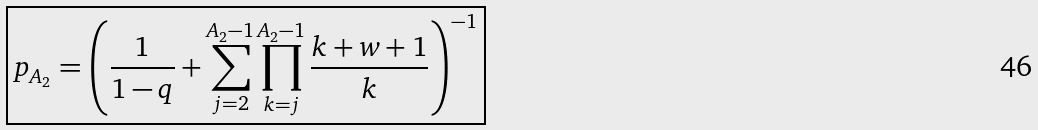<formula> <loc_0><loc_0><loc_500><loc_500>\boxed { p _ { A _ { 2 } } = \left ( \frac { 1 } { 1 - q } + \sum _ { j = 2 } ^ { A _ { 2 } - 1 } \prod _ { k = j } ^ { A _ { 2 } - 1 } \frac { k + w + 1 } { k } \right ) ^ { - 1 } }</formula> 